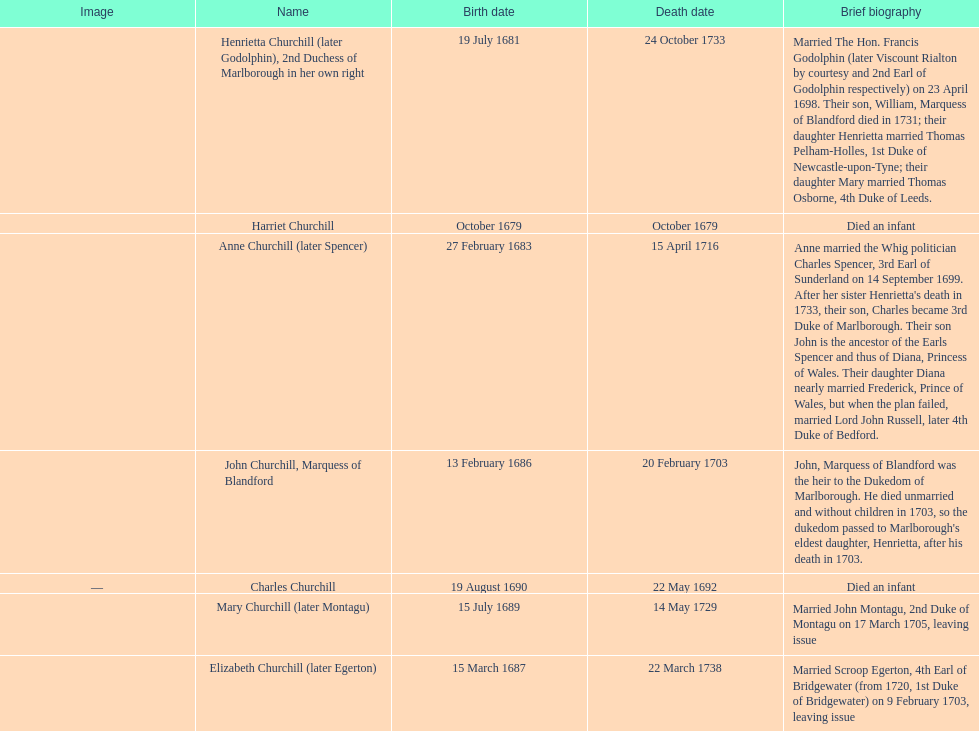Which child was born after elizabeth churchill? Mary Churchill. 